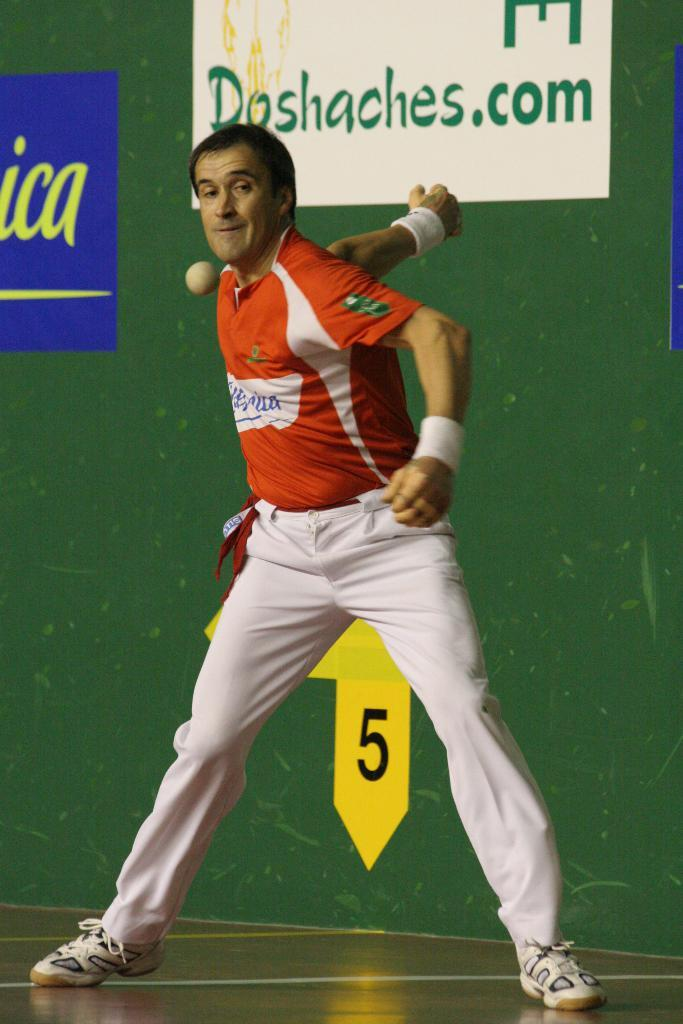<image>
Write a terse but informative summary of the picture. Man playing a sport in front of a sign that says "Doshaches". 